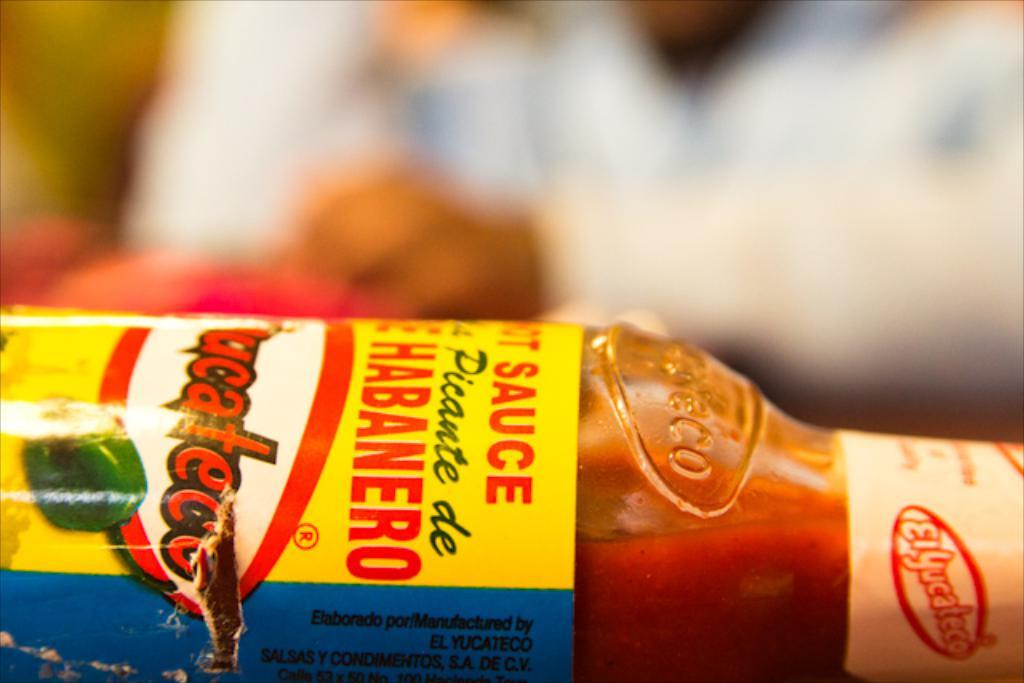What is the main object in the image? There is a hot chilli sauce bottle in the image. Can you describe the setting of the image? There are people sitting in the background of the image. What type of bomb is being used in the image? There is no bomb present in the image; it features a hot chilli sauce bottle and people sitting in the background. 